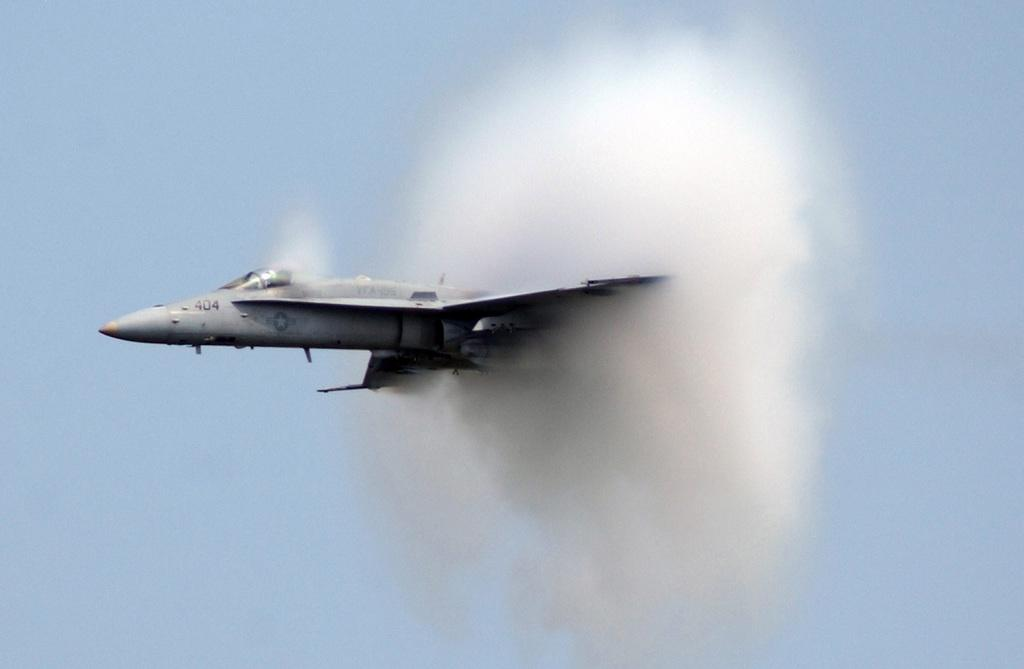<image>
Give a short and clear explanation of the subsequent image. A grey jet with the numbers 404 on it, flying through the sky with lots of smoke behind it. 